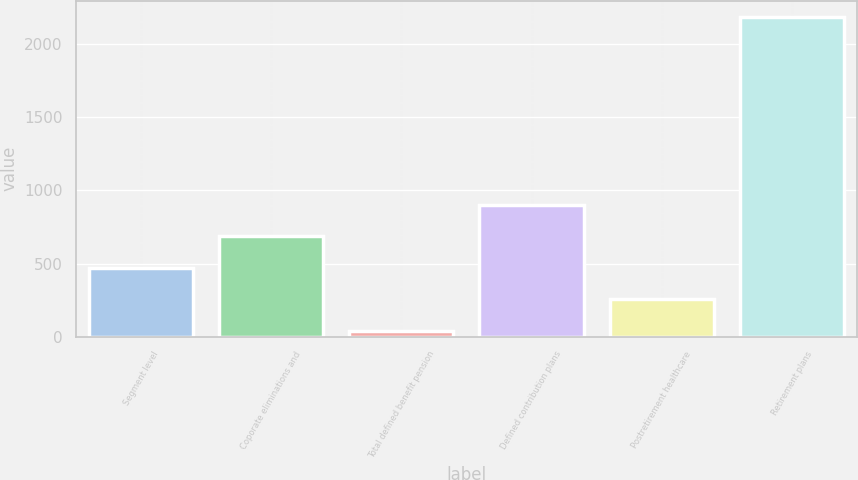Convert chart to OTSL. <chart><loc_0><loc_0><loc_500><loc_500><bar_chart><fcel>Segment level<fcel>Coporate eliminations and<fcel>Total defined benefit pension<fcel>Defined contribution plans<fcel>Postretirement healthcare<fcel>Retirement plans<nl><fcel>470.8<fcel>685.7<fcel>41<fcel>900.6<fcel>255.9<fcel>2190<nl></chart> 